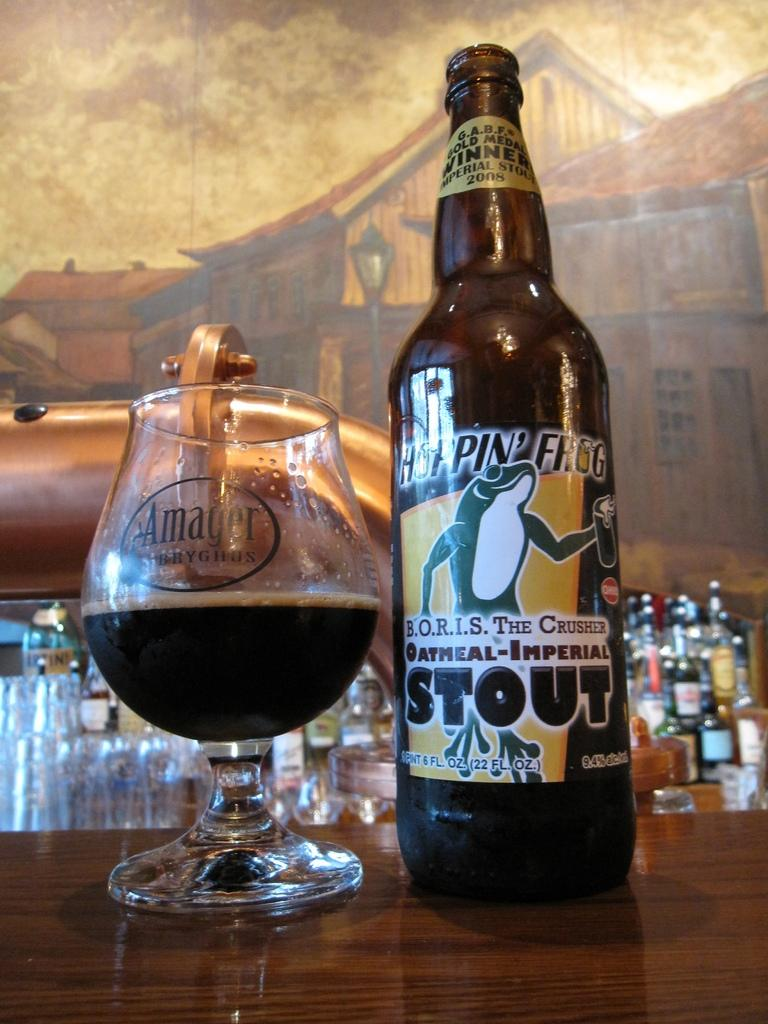<image>
Describe the image concisely. A bottle of Hoppin Frog Stout has been poured into a glass 